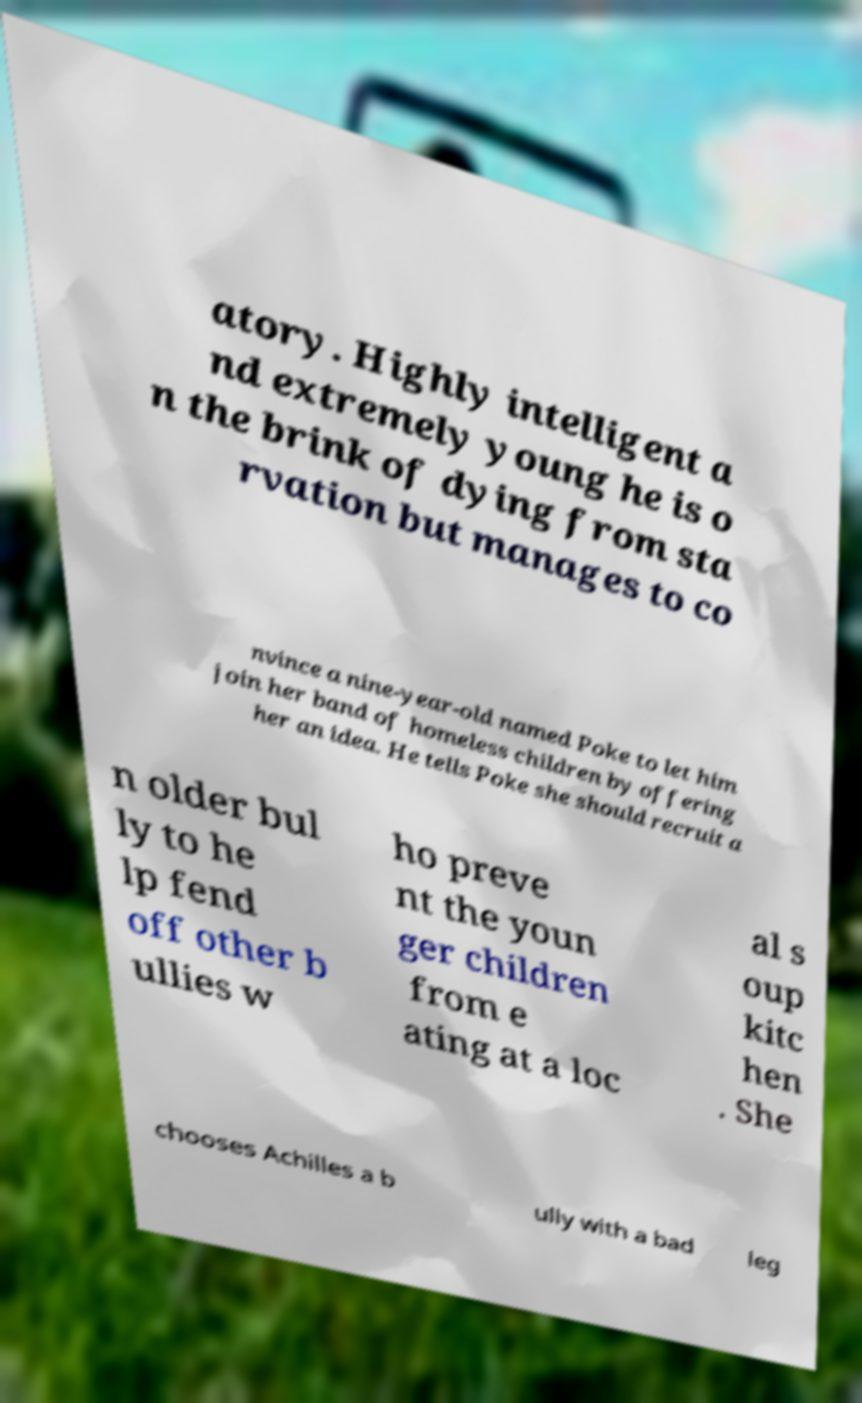Can you read and provide the text displayed in the image?This photo seems to have some interesting text. Can you extract and type it out for me? atory. Highly intelligent a nd extremely young he is o n the brink of dying from sta rvation but manages to co nvince a nine-year-old named Poke to let him join her band of homeless children by offering her an idea. He tells Poke she should recruit a n older bul ly to he lp fend off other b ullies w ho preve nt the youn ger children from e ating at a loc al s oup kitc hen . She chooses Achilles a b ully with a bad leg 